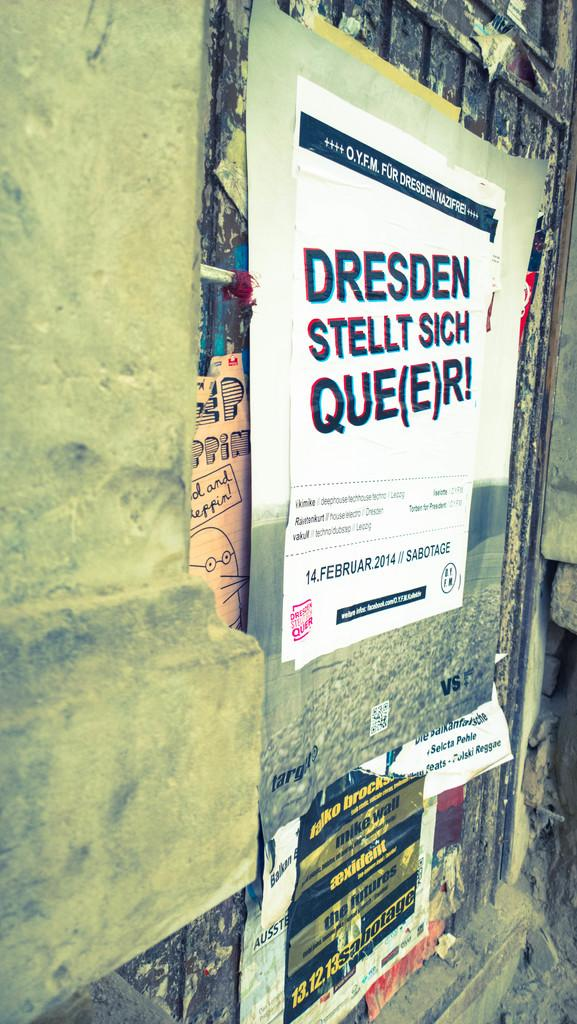Provide a one-sentence caption for the provided image. An advertisement on a wall for Dresden Stellt Sich Que(e)r! for February 14, 2014. 